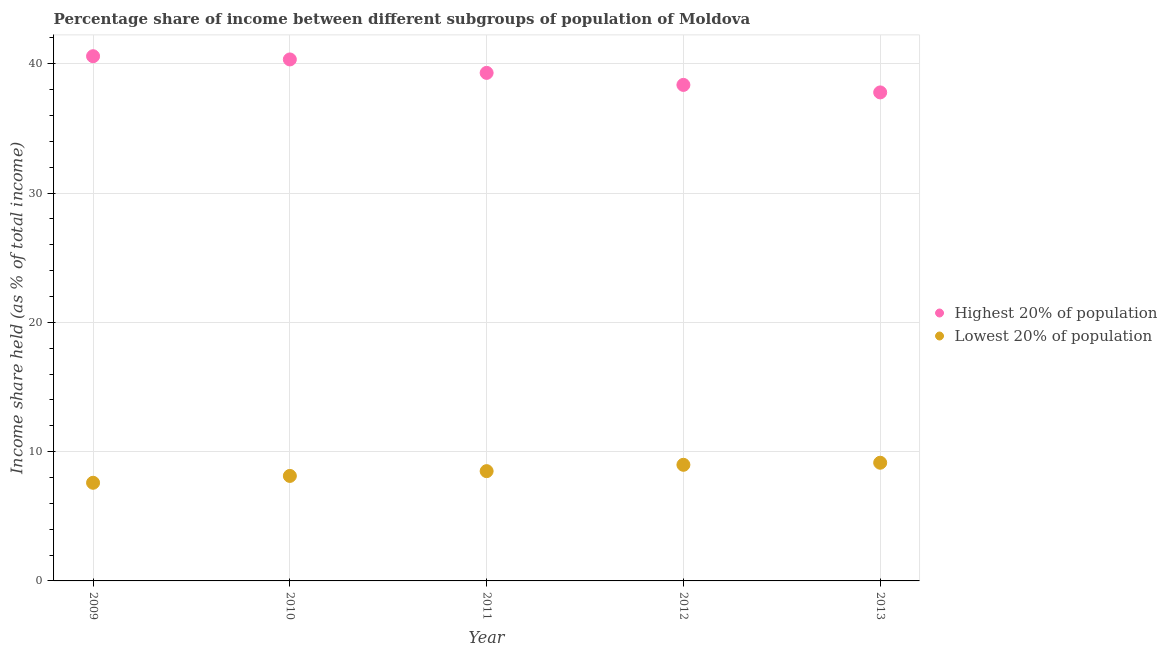How many different coloured dotlines are there?
Provide a succinct answer. 2. What is the income share held by highest 20% of the population in 2009?
Give a very brief answer. 40.58. Across all years, what is the maximum income share held by lowest 20% of the population?
Your answer should be compact. 9.14. Across all years, what is the minimum income share held by lowest 20% of the population?
Provide a short and direct response. 7.59. In which year was the income share held by highest 20% of the population maximum?
Your response must be concise. 2009. In which year was the income share held by lowest 20% of the population minimum?
Give a very brief answer. 2009. What is the total income share held by highest 20% of the population in the graph?
Offer a terse response. 196.34. What is the difference between the income share held by highest 20% of the population in 2012 and that in 2013?
Provide a succinct answer. 0.58. What is the difference between the income share held by highest 20% of the population in 2010 and the income share held by lowest 20% of the population in 2013?
Give a very brief answer. 31.19. What is the average income share held by lowest 20% of the population per year?
Provide a succinct answer. 8.46. In the year 2013, what is the difference between the income share held by lowest 20% of the population and income share held by highest 20% of the population?
Provide a succinct answer. -28.64. What is the ratio of the income share held by highest 20% of the population in 2011 to that in 2012?
Give a very brief answer. 1.02. What is the difference between the highest and the second highest income share held by lowest 20% of the population?
Your answer should be very brief. 0.16. What is the difference between the highest and the lowest income share held by lowest 20% of the population?
Offer a very short reply. 1.55. In how many years, is the income share held by highest 20% of the population greater than the average income share held by highest 20% of the population taken over all years?
Provide a succinct answer. 3. Does the income share held by highest 20% of the population monotonically increase over the years?
Offer a terse response. No. Is the income share held by lowest 20% of the population strictly less than the income share held by highest 20% of the population over the years?
Provide a short and direct response. Yes. How many dotlines are there?
Your response must be concise. 2. Does the graph contain any zero values?
Offer a very short reply. No. Does the graph contain grids?
Your answer should be very brief. Yes. How many legend labels are there?
Your answer should be compact. 2. How are the legend labels stacked?
Your answer should be compact. Vertical. What is the title of the graph?
Provide a succinct answer. Percentage share of income between different subgroups of population of Moldova. What is the label or title of the Y-axis?
Provide a succinct answer. Income share held (as % of total income). What is the Income share held (as % of total income) in Highest 20% of population in 2009?
Your response must be concise. 40.58. What is the Income share held (as % of total income) of Lowest 20% of population in 2009?
Keep it short and to the point. 7.59. What is the Income share held (as % of total income) in Highest 20% of population in 2010?
Offer a very short reply. 40.33. What is the Income share held (as % of total income) in Lowest 20% of population in 2010?
Offer a very short reply. 8.12. What is the Income share held (as % of total income) of Highest 20% of population in 2011?
Provide a succinct answer. 39.29. What is the Income share held (as % of total income) in Lowest 20% of population in 2011?
Ensure brevity in your answer.  8.49. What is the Income share held (as % of total income) of Highest 20% of population in 2012?
Keep it short and to the point. 38.36. What is the Income share held (as % of total income) of Lowest 20% of population in 2012?
Ensure brevity in your answer.  8.98. What is the Income share held (as % of total income) of Highest 20% of population in 2013?
Provide a succinct answer. 37.78. What is the Income share held (as % of total income) in Lowest 20% of population in 2013?
Provide a succinct answer. 9.14. Across all years, what is the maximum Income share held (as % of total income) in Highest 20% of population?
Your answer should be very brief. 40.58. Across all years, what is the maximum Income share held (as % of total income) in Lowest 20% of population?
Keep it short and to the point. 9.14. Across all years, what is the minimum Income share held (as % of total income) in Highest 20% of population?
Provide a short and direct response. 37.78. Across all years, what is the minimum Income share held (as % of total income) of Lowest 20% of population?
Keep it short and to the point. 7.59. What is the total Income share held (as % of total income) in Highest 20% of population in the graph?
Offer a terse response. 196.34. What is the total Income share held (as % of total income) in Lowest 20% of population in the graph?
Offer a terse response. 42.32. What is the difference between the Income share held (as % of total income) in Lowest 20% of population in 2009 and that in 2010?
Offer a terse response. -0.53. What is the difference between the Income share held (as % of total income) in Highest 20% of population in 2009 and that in 2011?
Your answer should be very brief. 1.29. What is the difference between the Income share held (as % of total income) of Highest 20% of population in 2009 and that in 2012?
Make the answer very short. 2.22. What is the difference between the Income share held (as % of total income) in Lowest 20% of population in 2009 and that in 2012?
Your answer should be compact. -1.39. What is the difference between the Income share held (as % of total income) of Lowest 20% of population in 2009 and that in 2013?
Provide a short and direct response. -1.55. What is the difference between the Income share held (as % of total income) of Highest 20% of population in 2010 and that in 2011?
Offer a very short reply. 1.04. What is the difference between the Income share held (as % of total income) of Lowest 20% of population in 2010 and that in 2011?
Ensure brevity in your answer.  -0.37. What is the difference between the Income share held (as % of total income) of Highest 20% of population in 2010 and that in 2012?
Your answer should be compact. 1.97. What is the difference between the Income share held (as % of total income) in Lowest 20% of population in 2010 and that in 2012?
Provide a succinct answer. -0.86. What is the difference between the Income share held (as % of total income) in Highest 20% of population in 2010 and that in 2013?
Offer a very short reply. 2.55. What is the difference between the Income share held (as % of total income) in Lowest 20% of population in 2010 and that in 2013?
Provide a short and direct response. -1.02. What is the difference between the Income share held (as % of total income) in Highest 20% of population in 2011 and that in 2012?
Make the answer very short. 0.93. What is the difference between the Income share held (as % of total income) of Lowest 20% of population in 2011 and that in 2012?
Ensure brevity in your answer.  -0.49. What is the difference between the Income share held (as % of total income) in Highest 20% of population in 2011 and that in 2013?
Make the answer very short. 1.51. What is the difference between the Income share held (as % of total income) of Lowest 20% of population in 2011 and that in 2013?
Keep it short and to the point. -0.65. What is the difference between the Income share held (as % of total income) in Highest 20% of population in 2012 and that in 2013?
Offer a very short reply. 0.58. What is the difference between the Income share held (as % of total income) of Lowest 20% of population in 2012 and that in 2013?
Provide a succinct answer. -0.16. What is the difference between the Income share held (as % of total income) of Highest 20% of population in 2009 and the Income share held (as % of total income) of Lowest 20% of population in 2010?
Offer a terse response. 32.46. What is the difference between the Income share held (as % of total income) in Highest 20% of population in 2009 and the Income share held (as % of total income) in Lowest 20% of population in 2011?
Provide a succinct answer. 32.09. What is the difference between the Income share held (as % of total income) of Highest 20% of population in 2009 and the Income share held (as % of total income) of Lowest 20% of population in 2012?
Provide a short and direct response. 31.6. What is the difference between the Income share held (as % of total income) of Highest 20% of population in 2009 and the Income share held (as % of total income) of Lowest 20% of population in 2013?
Ensure brevity in your answer.  31.44. What is the difference between the Income share held (as % of total income) of Highest 20% of population in 2010 and the Income share held (as % of total income) of Lowest 20% of population in 2011?
Give a very brief answer. 31.84. What is the difference between the Income share held (as % of total income) of Highest 20% of population in 2010 and the Income share held (as % of total income) of Lowest 20% of population in 2012?
Your answer should be very brief. 31.35. What is the difference between the Income share held (as % of total income) of Highest 20% of population in 2010 and the Income share held (as % of total income) of Lowest 20% of population in 2013?
Your response must be concise. 31.19. What is the difference between the Income share held (as % of total income) in Highest 20% of population in 2011 and the Income share held (as % of total income) in Lowest 20% of population in 2012?
Provide a short and direct response. 30.31. What is the difference between the Income share held (as % of total income) of Highest 20% of population in 2011 and the Income share held (as % of total income) of Lowest 20% of population in 2013?
Offer a very short reply. 30.15. What is the difference between the Income share held (as % of total income) of Highest 20% of population in 2012 and the Income share held (as % of total income) of Lowest 20% of population in 2013?
Offer a very short reply. 29.22. What is the average Income share held (as % of total income) of Highest 20% of population per year?
Your response must be concise. 39.27. What is the average Income share held (as % of total income) of Lowest 20% of population per year?
Your answer should be compact. 8.46. In the year 2009, what is the difference between the Income share held (as % of total income) in Highest 20% of population and Income share held (as % of total income) in Lowest 20% of population?
Your answer should be very brief. 32.99. In the year 2010, what is the difference between the Income share held (as % of total income) in Highest 20% of population and Income share held (as % of total income) in Lowest 20% of population?
Provide a succinct answer. 32.21. In the year 2011, what is the difference between the Income share held (as % of total income) in Highest 20% of population and Income share held (as % of total income) in Lowest 20% of population?
Provide a succinct answer. 30.8. In the year 2012, what is the difference between the Income share held (as % of total income) in Highest 20% of population and Income share held (as % of total income) in Lowest 20% of population?
Give a very brief answer. 29.38. In the year 2013, what is the difference between the Income share held (as % of total income) in Highest 20% of population and Income share held (as % of total income) in Lowest 20% of population?
Your answer should be very brief. 28.64. What is the ratio of the Income share held (as % of total income) in Highest 20% of population in 2009 to that in 2010?
Make the answer very short. 1.01. What is the ratio of the Income share held (as % of total income) of Lowest 20% of population in 2009 to that in 2010?
Offer a terse response. 0.93. What is the ratio of the Income share held (as % of total income) of Highest 20% of population in 2009 to that in 2011?
Give a very brief answer. 1.03. What is the ratio of the Income share held (as % of total income) of Lowest 20% of population in 2009 to that in 2011?
Provide a succinct answer. 0.89. What is the ratio of the Income share held (as % of total income) of Highest 20% of population in 2009 to that in 2012?
Your response must be concise. 1.06. What is the ratio of the Income share held (as % of total income) of Lowest 20% of population in 2009 to that in 2012?
Your response must be concise. 0.85. What is the ratio of the Income share held (as % of total income) in Highest 20% of population in 2009 to that in 2013?
Your answer should be very brief. 1.07. What is the ratio of the Income share held (as % of total income) of Lowest 20% of population in 2009 to that in 2013?
Offer a terse response. 0.83. What is the ratio of the Income share held (as % of total income) of Highest 20% of population in 2010 to that in 2011?
Provide a succinct answer. 1.03. What is the ratio of the Income share held (as % of total income) in Lowest 20% of population in 2010 to that in 2011?
Give a very brief answer. 0.96. What is the ratio of the Income share held (as % of total income) in Highest 20% of population in 2010 to that in 2012?
Provide a succinct answer. 1.05. What is the ratio of the Income share held (as % of total income) in Lowest 20% of population in 2010 to that in 2012?
Ensure brevity in your answer.  0.9. What is the ratio of the Income share held (as % of total income) in Highest 20% of population in 2010 to that in 2013?
Your answer should be very brief. 1.07. What is the ratio of the Income share held (as % of total income) in Lowest 20% of population in 2010 to that in 2013?
Give a very brief answer. 0.89. What is the ratio of the Income share held (as % of total income) in Highest 20% of population in 2011 to that in 2012?
Provide a succinct answer. 1.02. What is the ratio of the Income share held (as % of total income) of Lowest 20% of population in 2011 to that in 2012?
Provide a succinct answer. 0.95. What is the ratio of the Income share held (as % of total income) in Highest 20% of population in 2011 to that in 2013?
Provide a succinct answer. 1.04. What is the ratio of the Income share held (as % of total income) in Lowest 20% of population in 2011 to that in 2013?
Give a very brief answer. 0.93. What is the ratio of the Income share held (as % of total income) of Highest 20% of population in 2012 to that in 2013?
Offer a terse response. 1.02. What is the ratio of the Income share held (as % of total income) in Lowest 20% of population in 2012 to that in 2013?
Your answer should be very brief. 0.98. What is the difference between the highest and the second highest Income share held (as % of total income) in Highest 20% of population?
Your response must be concise. 0.25. What is the difference between the highest and the second highest Income share held (as % of total income) in Lowest 20% of population?
Your answer should be very brief. 0.16. What is the difference between the highest and the lowest Income share held (as % of total income) in Highest 20% of population?
Offer a terse response. 2.8. What is the difference between the highest and the lowest Income share held (as % of total income) of Lowest 20% of population?
Your answer should be very brief. 1.55. 